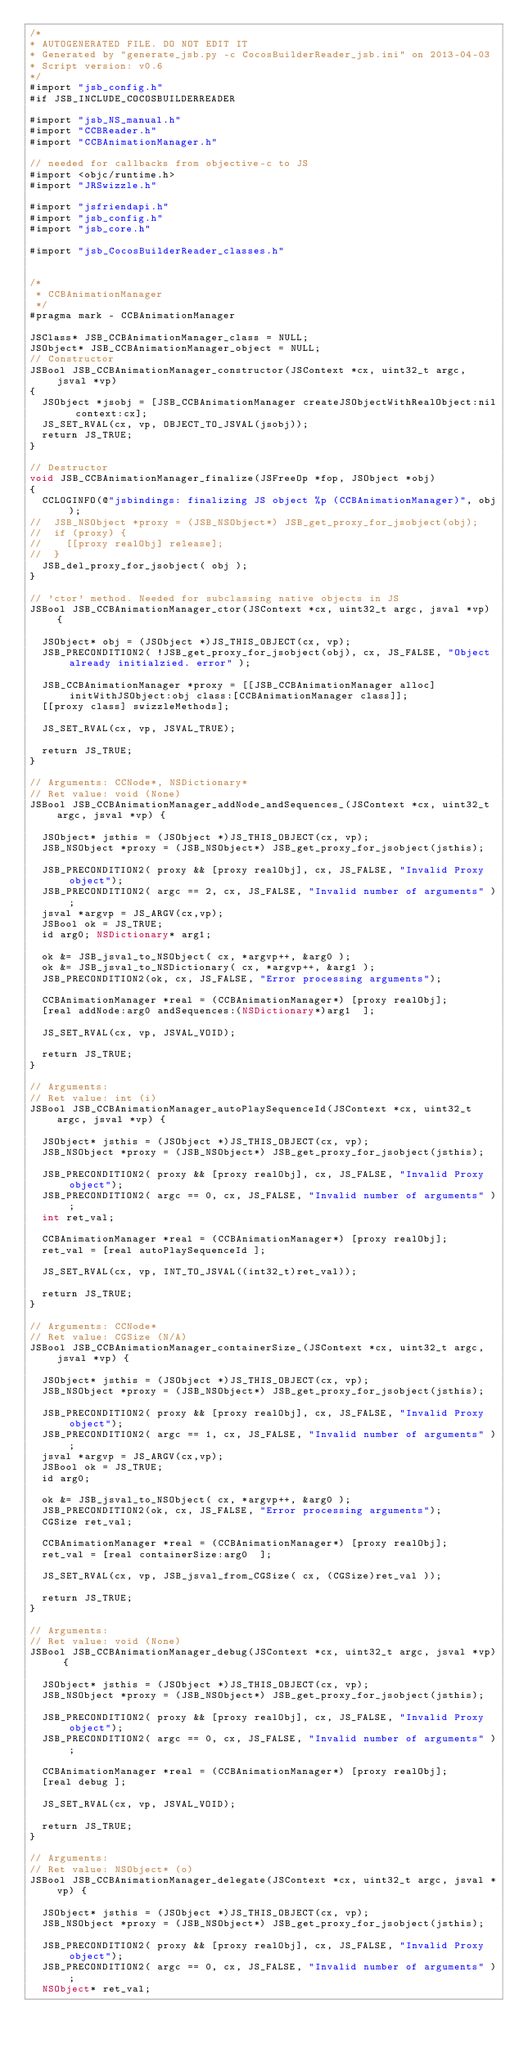Convert code to text. <code><loc_0><loc_0><loc_500><loc_500><_ObjectiveC_>/*
* AUTOGENERATED FILE. DO NOT EDIT IT
* Generated by "generate_jsb.py -c CocosBuilderReader_jsb.ini" on 2013-04-03
* Script version: v0.6
*/
#import "jsb_config.h"
#if JSB_INCLUDE_COCOSBUILDERREADER

#import "jsb_NS_manual.h"
#import "CCBReader.h"
#import "CCBAnimationManager.h"

// needed for callbacks from objective-c to JS
#import <objc/runtime.h>
#import "JRSwizzle.h"

#import "jsfriendapi.h"
#import "jsb_config.h"
#import "jsb_core.h"

#import "jsb_CocosBuilderReader_classes.h"


/*
 * CCBAnimationManager
 */
#pragma mark - CCBAnimationManager

JSClass* JSB_CCBAnimationManager_class = NULL;
JSObject* JSB_CCBAnimationManager_object = NULL;
// Constructor
JSBool JSB_CCBAnimationManager_constructor(JSContext *cx, uint32_t argc, jsval *vp)
{
	JSObject *jsobj = [JSB_CCBAnimationManager createJSObjectWithRealObject:nil context:cx];
	JS_SET_RVAL(cx, vp, OBJECT_TO_JSVAL(jsobj));
	return JS_TRUE;
}

// Destructor
void JSB_CCBAnimationManager_finalize(JSFreeOp *fop, JSObject *obj)
{
	CCLOGINFO(@"jsbindings: finalizing JS object %p (CCBAnimationManager)", obj);
//	JSB_NSObject *proxy = (JSB_NSObject*) JSB_get_proxy_for_jsobject(obj);
//	if (proxy) {
//		[[proxy realObj] release];
//	}
	JSB_del_proxy_for_jsobject( obj );
}

// 'ctor' method. Needed for subclassing native objects in JS
JSBool JSB_CCBAnimationManager_ctor(JSContext *cx, uint32_t argc, jsval *vp) {

	JSObject* obj = (JSObject *)JS_THIS_OBJECT(cx, vp);
	JSB_PRECONDITION2( !JSB_get_proxy_for_jsobject(obj), cx, JS_FALSE, "Object already initialzied. error" );

	JSB_CCBAnimationManager *proxy = [[JSB_CCBAnimationManager alloc] initWithJSObject:obj class:[CCBAnimationManager class]];
	[[proxy class] swizzleMethods];

	JS_SET_RVAL(cx, vp, JSVAL_TRUE);

	return JS_TRUE;
}

// Arguments: CCNode*, NSDictionary*
// Ret value: void (None)
JSBool JSB_CCBAnimationManager_addNode_andSequences_(JSContext *cx, uint32_t argc, jsval *vp) {

	JSObject* jsthis = (JSObject *)JS_THIS_OBJECT(cx, vp);
	JSB_NSObject *proxy = (JSB_NSObject*) JSB_get_proxy_for_jsobject(jsthis);

	JSB_PRECONDITION2( proxy && [proxy realObj], cx, JS_FALSE, "Invalid Proxy object");
	JSB_PRECONDITION2( argc == 2, cx, JS_FALSE, "Invalid number of arguments" );
	jsval *argvp = JS_ARGV(cx,vp);
	JSBool ok = JS_TRUE;
	id arg0; NSDictionary* arg1; 

	ok &= JSB_jsval_to_NSObject( cx, *argvp++, &arg0 );
	ok &= JSB_jsval_to_NSDictionary( cx, *argvp++, &arg1 );
	JSB_PRECONDITION2(ok, cx, JS_FALSE, "Error processing arguments");

	CCBAnimationManager *real = (CCBAnimationManager*) [proxy realObj];
	[real addNode:arg0 andSequences:(NSDictionary*)arg1  ];

	JS_SET_RVAL(cx, vp, JSVAL_VOID);

	return JS_TRUE;
}

// Arguments: 
// Ret value: int (i)
JSBool JSB_CCBAnimationManager_autoPlaySequenceId(JSContext *cx, uint32_t argc, jsval *vp) {

	JSObject* jsthis = (JSObject *)JS_THIS_OBJECT(cx, vp);
	JSB_NSObject *proxy = (JSB_NSObject*) JSB_get_proxy_for_jsobject(jsthis);

	JSB_PRECONDITION2( proxy && [proxy realObj], cx, JS_FALSE, "Invalid Proxy object");
	JSB_PRECONDITION2( argc == 0, cx, JS_FALSE, "Invalid number of arguments" );
	int ret_val;

	CCBAnimationManager *real = (CCBAnimationManager*) [proxy realObj];
	ret_val = [real autoPlaySequenceId ];

	JS_SET_RVAL(cx, vp, INT_TO_JSVAL((int32_t)ret_val));

	return JS_TRUE;
}

// Arguments: CCNode*
// Ret value: CGSize (N/A)
JSBool JSB_CCBAnimationManager_containerSize_(JSContext *cx, uint32_t argc, jsval *vp) {

	JSObject* jsthis = (JSObject *)JS_THIS_OBJECT(cx, vp);
	JSB_NSObject *proxy = (JSB_NSObject*) JSB_get_proxy_for_jsobject(jsthis);

	JSB_PRECONDITION2( proxy && [proxy realObj], cx, JS_FALSE, "Invalid Proxy object");
	JSB_PRECONDITION2( argc == 1, cx, JS_FALSE, "Invalid number of arguments" );
	jsval *argvp = JS_ARGV(cx,vp);
	JSBool ok = JS_TRUE;
	id arg0; 

	ok &= JSB_jsval_to_NSObject( cx, *argvp++, &arg0 );
	JSB_PRECONDITION2(ok, cx, JS_FALSE, "Error processing arguments");
	CGSize ret_val;

	CCBAnimationManager *real = (CCBAnimationManager*) [proxy realObj];
	ret_val = [real containerSize:arg0  ];

	JS_SET_RVAL(cx, vp, JSB_jsval_from_CGSize( cx, (CGSize)ret_val ));

	return JS_TRUE;
}

// Arguments: 
// Ret value: void (None)
JSBool JSB_CCBAnimationManager_debug(JSContext *cx, uint32_t argc, jsval *vp) {

	JSObject* jsthis = (JSObject *)JS_THIS_OBJECT(cx, vp);
	JSB_NSObject *proxy = (JSB_NSObject*) JSB_get_proxy_for_jsobject(jsthis);

	JSB_PRECONDITION2( proxy && [proxy realObj], cx, JS_FALSE, "Invalid Proxy object");
	JSB_PRECONDITION2( argc == 0, cx, JS_FALSE, "Invalid number of arguments" );

	CCBAnimationManager *real = (CCBAnimationManager*) [proxy realObj];
	[real debug ];

	JS_SET_RVAL(cx, vp, JSVAL_VOID);

	return JS_TRUE;
}

// Arguments: 
// Ret value: NSObject* (o)
JSBool JSB_CCBAnimationManager_delegate(JSContext *cx, uint32_t argc, jsval *vp) {

	JSObject* jsthis = (JSObject *)JS_THIS_OBJECT(cx, vp);
	JSB_NSObject *proxy = (JSB_NSObject*) JSB_get_proxy_for_jsobject(jsthis);

	JSB_PRECONDITION2( proxy && [proxy realObj], cx, JS_FALSE, "Invalid Proxy object");
	JSB_PRECONDITION2( argc == 0, cx, JS_FALSE, "Invalid number of arguments" );
	NSObject* ret_val;
</code> 